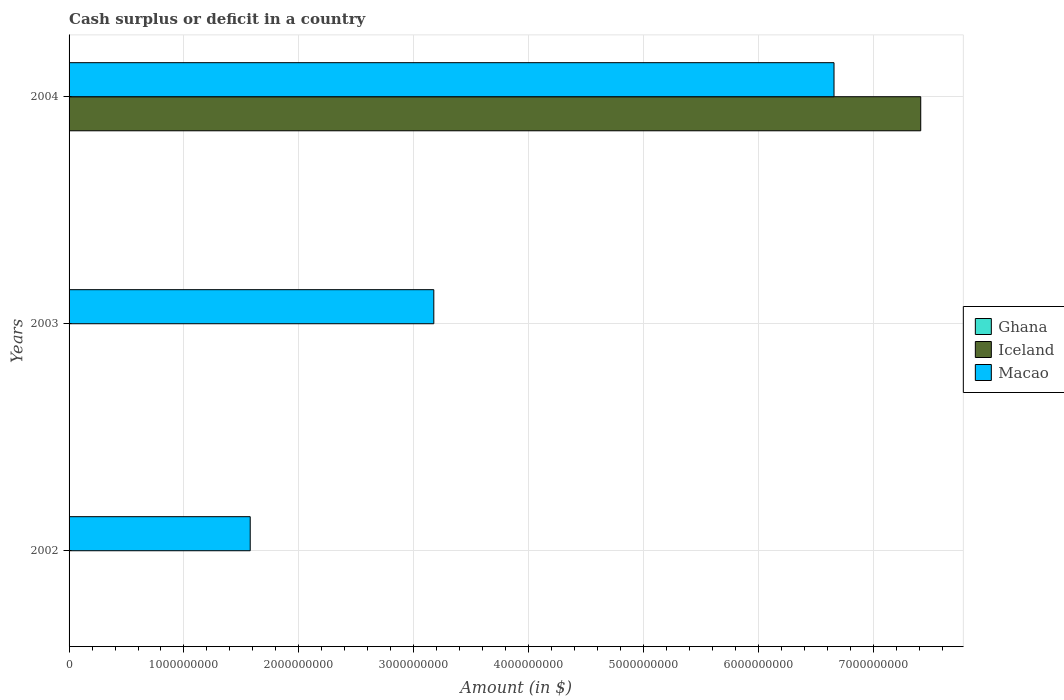Are the number of bars per tick equal to the number of legend labels?
Keep it short and to the point. No. How many bars are there on the 3rd tick from the bottom?
Provide a succinct answer. 2. What is the label of the 3rd group of bars from the top?
Provide a succinct answer. 2002. Across all years, what is the maximum amount of cash surplus or deficit in Macao?
Provide a succinct answer. 6.66e+09. What is the total amount of cash surplus or deficit in Iceland in the graph?
Your answer should be compact. 7.41e+09. What is the difference between the amount of cash surplus or deficit in Macao in 2002 and that in 2003?
Your response must be concise. -1.60e+09. What is the difference between the amount of cash surplus or deficit in Ghana in 2003 and the amount of cash surplus or deficit in Macao in 2002?
Provide a short and direct response. -1.58e+09. What is the average amount of cash surplus or deficit in Iceland per year?
Provide a short and direct response. 2.47e+09. In how many years, is the amount of cash surplus or deficit in Macao greater than 5600000000 $?
Provide a succinct answer. 1. What is the ratio of the amount of cash surplus or deficit in Macao in 2002 to that in 2003?
Your answer should be very brief. 0.5. What is the difference between the highest and the second highest amount of cash surplus or deficit in Macao?
Provide a succinct answer. 3.48e+09. What is the difference between the highest and the lowest amount of cash surplus or deficit in Iceland?
Your answer should be very brief. 7.41e+09. Is it the case that in every year, the sum of the amount of cash surplus or deficit in Ghana and amount of cash surplus or deficit in Macao is greater than the amount of cash surplus or deficit in Iceland?
Keep it short and to the point. No. How many bars are there?
Your answer should be compact. 4. What is the difference between two consecutive major ticks on the X-axis?
Offer a very short reply. 1.00e+09. How many legend labels are there?
Give a very brief answer. 3. What is the title of the graph?
Your answer should be compact. Cash surplus or deficit in a country. Does "Liberia" appear as one of the legend labels in the graph?
Ensure brevity in your answer.  No. What is the label or title of the X-axis?
Your answer should be compact. Amount (in $). What is the label or title of the Y-axis?
Provide a short and direct response. Years. What is the Amount (in $) of Ghana in 2002?
Your response must be concise. 0. What is the Amount (in $) of Iceland in 2002?
Provide a short and direct response. 0. What is the Amount (in $) of Macao in 2002?
Make the answer very short. 1.58e+09. What is the Amount (in $) of Ghana in 2003?
Keep it short and to the point. 0. What is the Amount (in $) in Iceland in 2003?
Provide a short and direct response. 0. What is the Amount (in $) in Macao in 2003?
Keep it short and to the point. 3.17e+09. What is the Amount (in $) in Iceland in 2004?
Offer a very short reply. 7.41e+09. What is the Amount (in $) of Macao in 2004?
Your response must be concise. 6.66e+09. Across all years, what is the maximum Amount (in $) of Iceland?
Provide a short and direct response. 7.41e+09. Across all years, what is the maximum Amount (in $) in Macao?
Give a very brief answer. 6.66e+09. Across all years, what is the minimum Amount (in $) of Macao?
Offer a terse response. 1.58e+09. What is the total Amount (in $) in Ghana in the graph?
Ensure brevity in your answer.  0. What is the total Amount (in $) of Iceland in the graph?
Make the answer very short. 7.41e+09. What is the total Amount (in $) of Macao in the graph?
Offer a terse response. 1.14e+1. What is the difference between the Amount (in $) of Macao in 2002 and that in 2003?
Ensure brevity in your answer.  -1.60e+09. What is the difference between the Amount (in $) in Macao in 2002 and that in 2004?
Offer a very short reply. -5.08e+09. What is the difference between the Amount (in $) in Macao in 2003 and that in 2004?
Ensure brevity in your answer.  -3.48e+09. What is the average Amount (in $) in Ghana per year?
Provide a succinct answer. 0. What is the average Amount (in $) in Iceland per year?
Offer a terse response. 2.47e+09. What is the average Amount (in $) of Macao per year?
Ensure brevity in your answer.  3.80e+09. In the year 2004, what is the difference between the Amount (in $) of Iceland and Amount (in $) of Macao?
Offer a terse response. 7.55e+08. What is the ratio of the Amount (in $) of Macao in 2002 to that in 2003?
Provide a short and direct response. 0.5. What is the ratio of the Amount (in $) of Macao in 2002 to that in 2004?
Give a very brief answer. 0.24. What is the ratio of the Amount (in $) in Macao in 2003 to that in 2004?
Provide a short and direct response. 0.48. What is the difference between the highest and the second highest Amount (in $) of Macao?
Your response must be concise. 3.48e+09. What is the difference between the highest and the lowest Amount (in $) in Iceland?
Offer a very short reply. 7.41e+09. What is the difference between the highest and the lowest Amount (in $) of Macao?
Offer a terse response. 5.08e+09. 